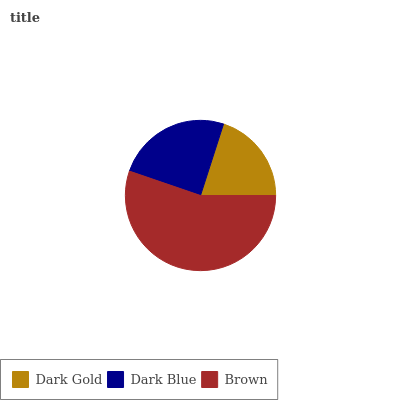Is Dark Gold the minimum?
Answer yes or no. Yes. Is Brown the maximum?
Answer yes or no. Yes. Is Dark Blue the minimum?
Answer yes or no. No. Is Dark Blue the maximum?
Answer yes or no. No. Is Dark Blue greater than Dark Gold?
Answer yes or no. Yes. Is Dark Gold less than Dark Blue?
Answer yes or no. Yes. Is Dark Gold greater than Dark Blue?
Answer yes or no. No. Is Dark Blue less than Dark Gold?
Answer yes or no. No. Is Dark Blue the high median?
Answer yes or no. Yes. Is Dark Blue the low median?
Answer yes or no. Yes. Is Dark Gold the high median?
Answer yes or no. No. Is Brown the low median?
Answer yes or no. No. 